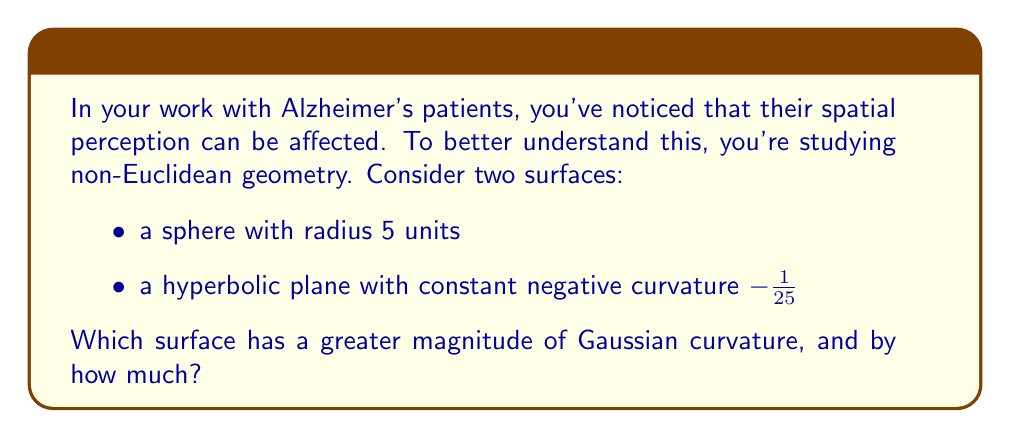What is the answer to this math problem? Let's approach this step-by-step:

1) For a sphere, the Gaussian curvature K is constant and given by:
   $$K_{sphere} = \frac{1}{R^2}$$
   where R is the radius of the sphere.

2) Given that the sphere has a radius of 5 units:
   $$K_{sphere} = \frac{1}{5^2} = \frac{1}{25} = 0.04$$

3) For the hyperbolic plane, we're given that the constant negative curvature is -1/25:
   $$K_{hyperbolic} = -\frac{1}{25} = -0.04$$

4) To compare magnitudes, we take the absolute value:
   $$|K_{sphere}| = |\frac{1}{25}| = 0.04$$
   $$|K_{hyperbolic}| = |-\frac{1}{25}| = 0.04$$

5) We can see that the magnitudes are equal:
   $$|K_{sphere}| = |K_{hyperbolic}| = 0.04$$

6) The difference in magnitude is:
   $$|K_{sphere}| - |K_{hyperbolic}| = 0.04 - 0.04 = 0$$

Therefore, neither surface has a greater magnitude of Gaussian curvature; they are equal in magnitude.
Answer: Neither; equal magnitude 